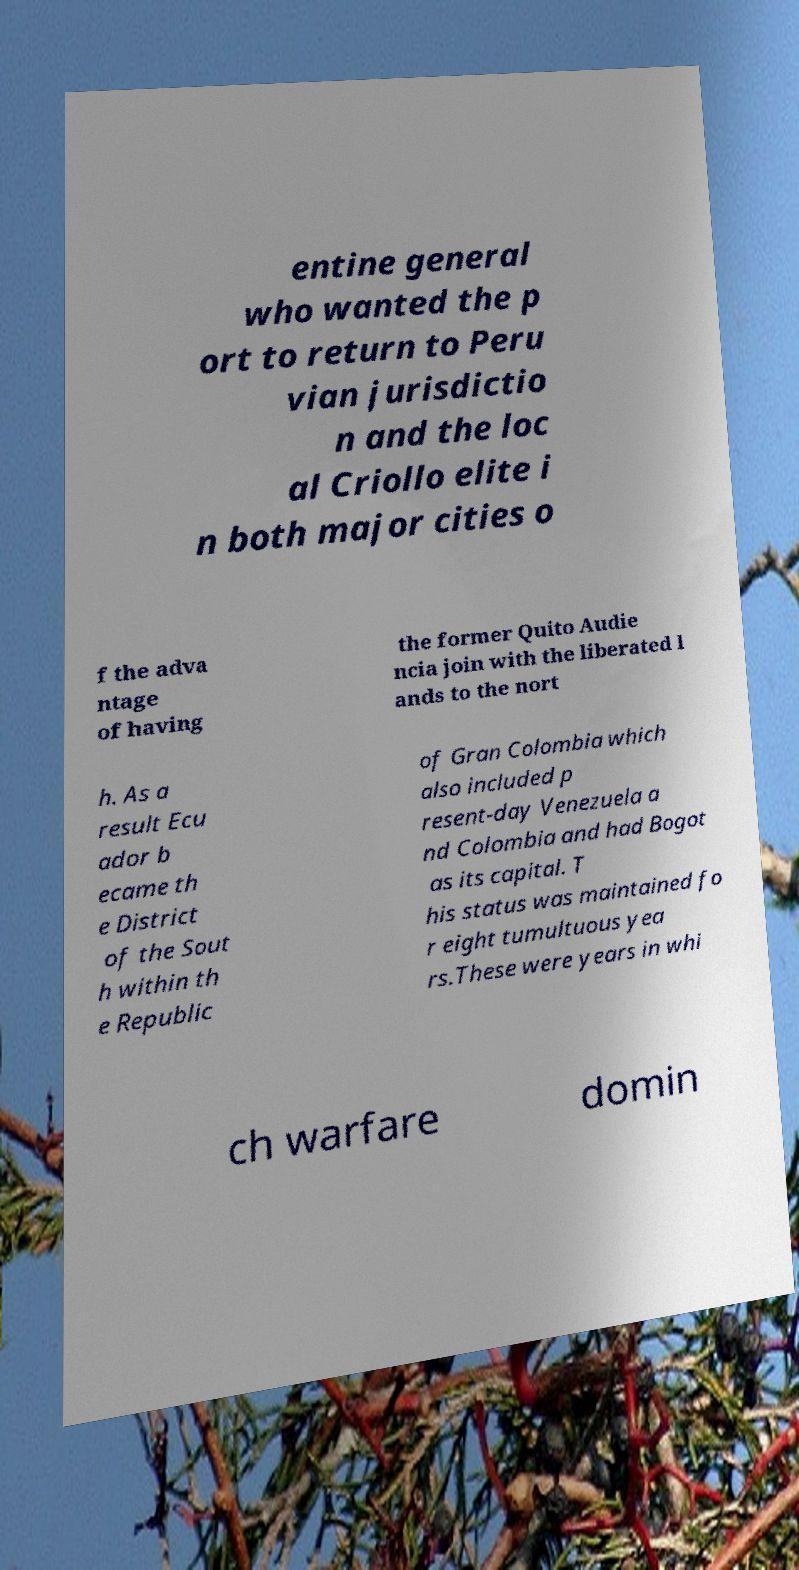Can you accurately transcribe the text from the provided image for me? entine general who wanted the p ort to return to Peru vian jurisdictio n and the loc al Criollo elite i n both major cities o f the adva ntage of having the former Quito Audie ncia join with the liberated l ands to the nort h. As a result Ecu ador b ecame th e District of the Sout h within th e Republic of Gran Colombia which also included p resent-day Venezuela a nd Colombia and had Bogot as its capital. T his status was maintained fo r eight tumultuous yea rs.These were years in whi ch warfare domin 